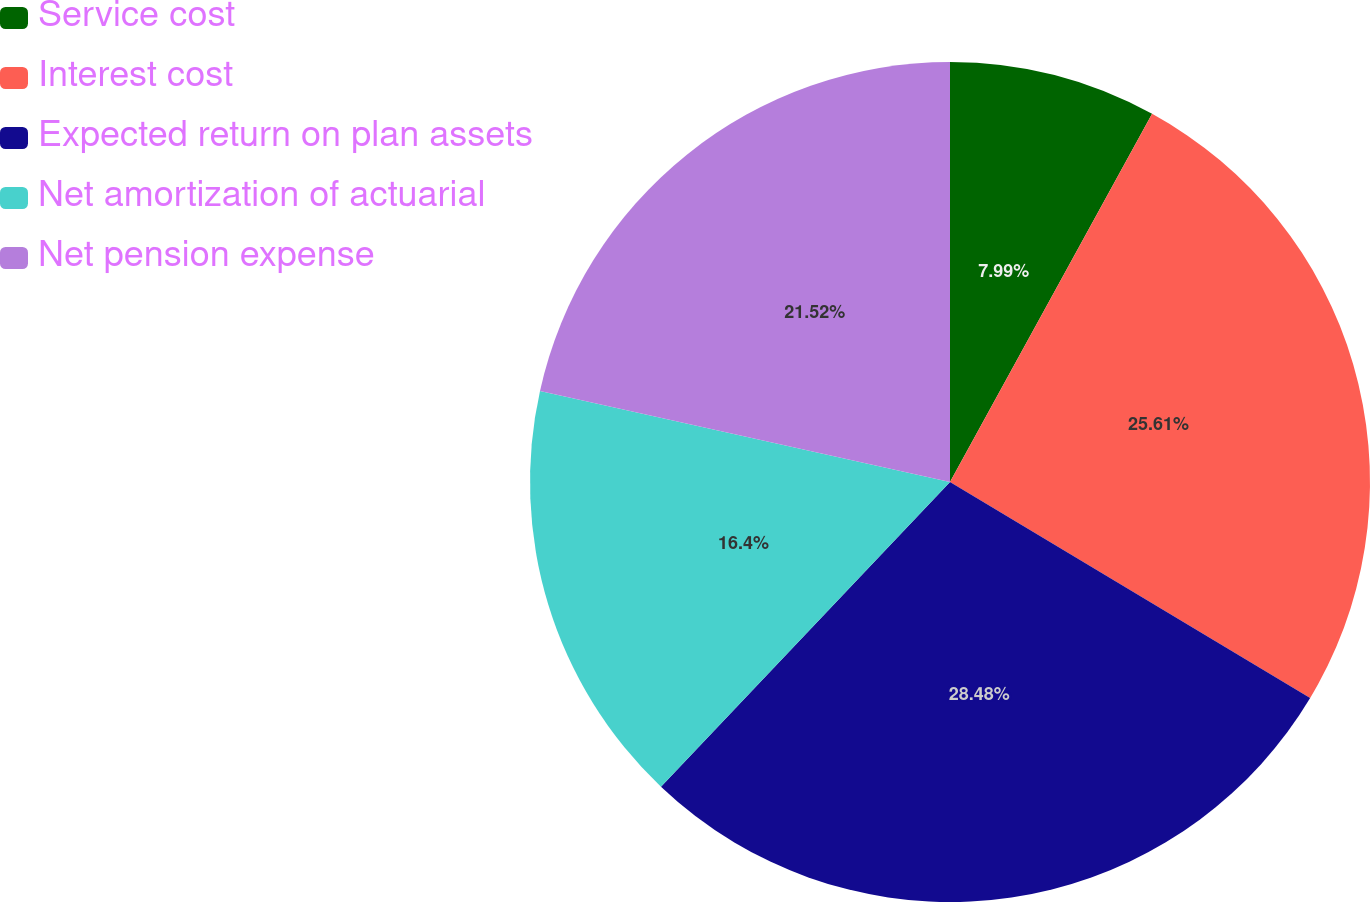Convert chart. <chart><loc_0><loc_0><loc_500><loc_500><pie_chart><fcel>Service cost<fcel>Interest cost<fcel>Expected return on plan assets<fcel>Net amortization of actuarial<fcel>Net pension expense<nl><fcel>7.99%<fcel>25.61%<fcel>28.48%<fcel>16.4%<fcel>21.52%<nl></chart> 